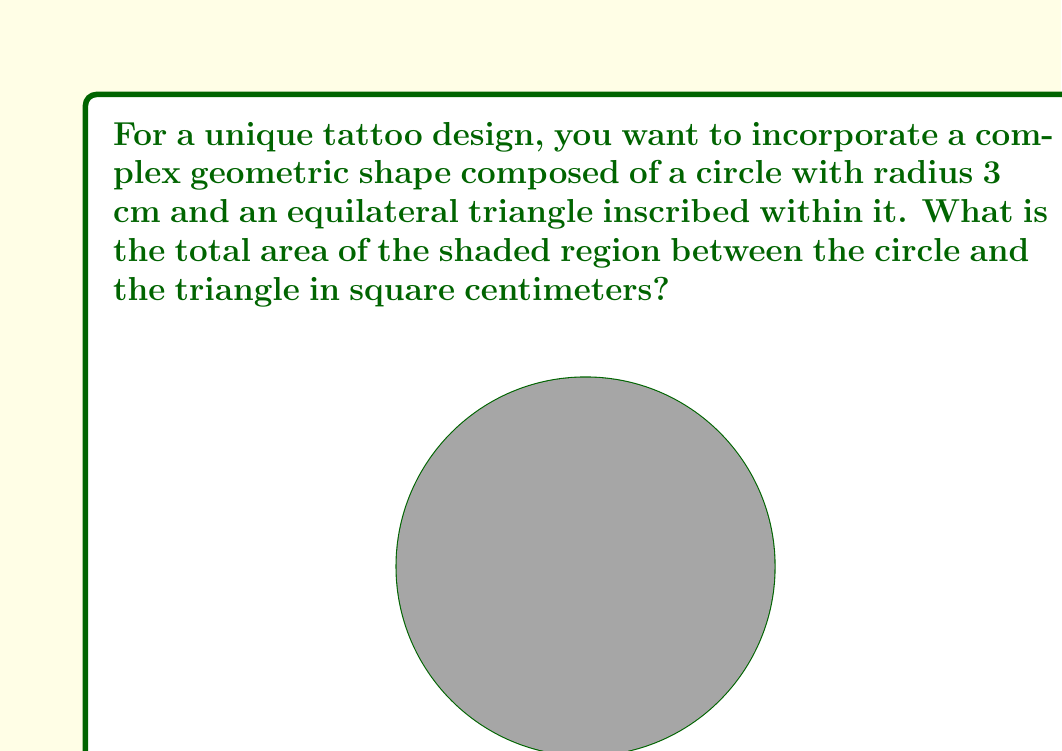Can you solve this math problem? To solve this problem, we need to follow these steps:

1. Calculate the area of the circle:
   $$A_{circle} = \pi r^2 = \pi \cdot 3^2 = 9\pi \text{ cm}^2$$

2. Calculate the area of the equilateral triangle:
   First, we need to find the side length of the triangle. In an equilateral triangle inscribed in a circle, the side length $s$ is related to the radius $r$ by:
   $$s = r\sqrt{3}$$
   So, $s = 3\sqrt{3} \text{ cm}$

   The area of an equilateral triangle with side length $s$ is:
   $$A_{triangle} = \frac{\sqrt{3}}{4}s^2 = \frac{\sqrt{3}}{4}(3\sqrt{3})^2 = \frac{27\sqrt{3}}{4} \text{ cm}^2$$

3. The shaded area is the difference between the circle's area and the triangle's area:
   $$A_{shaded} = A_{circle} - A_{triangle} = 9\pi - \frac{27\sqrt{3}}{4} \text{ cm}^2$$

4. Simplify the expression:
   $$A_{shaded} = 9\pi - \frac{27\sqrt{3}}{4} \approx 11.7477 \text{ cm}^2$$
Answer: $9\pi - \frac{27\sqrt{3}}{4} \approx 11.7477 \text{ cm}^2$ 